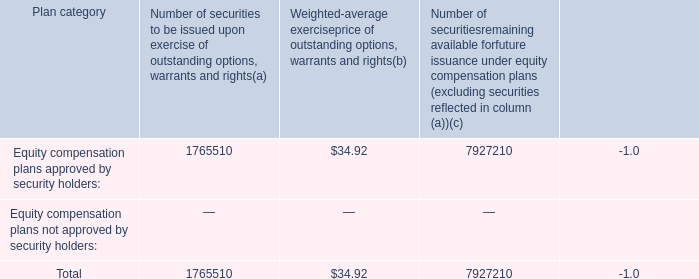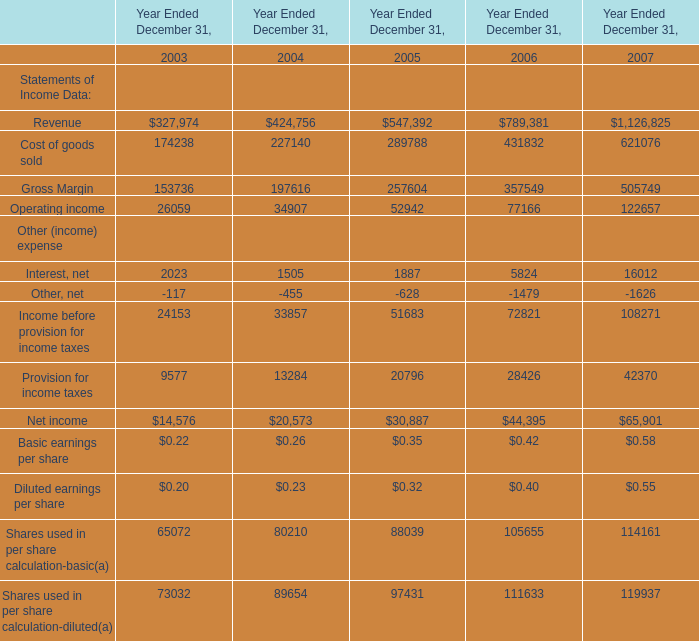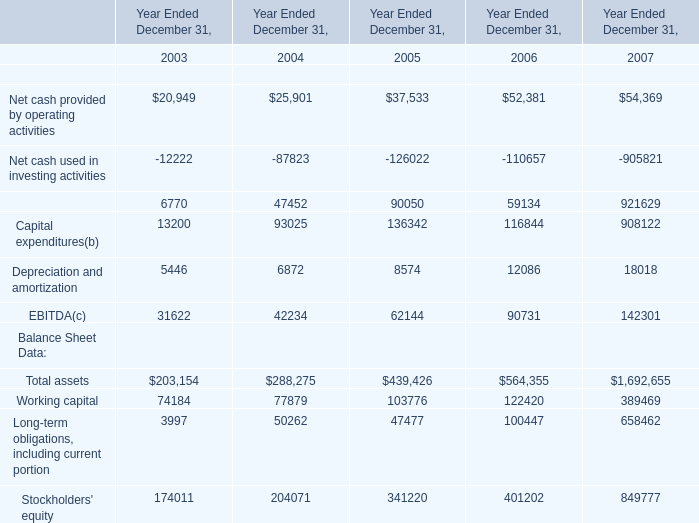what is the total value of securities approved by security holders , ( in millions ) ? 
Computations: ((1765510 * 34.92) / 1000000)
Answer: 61.65161. 